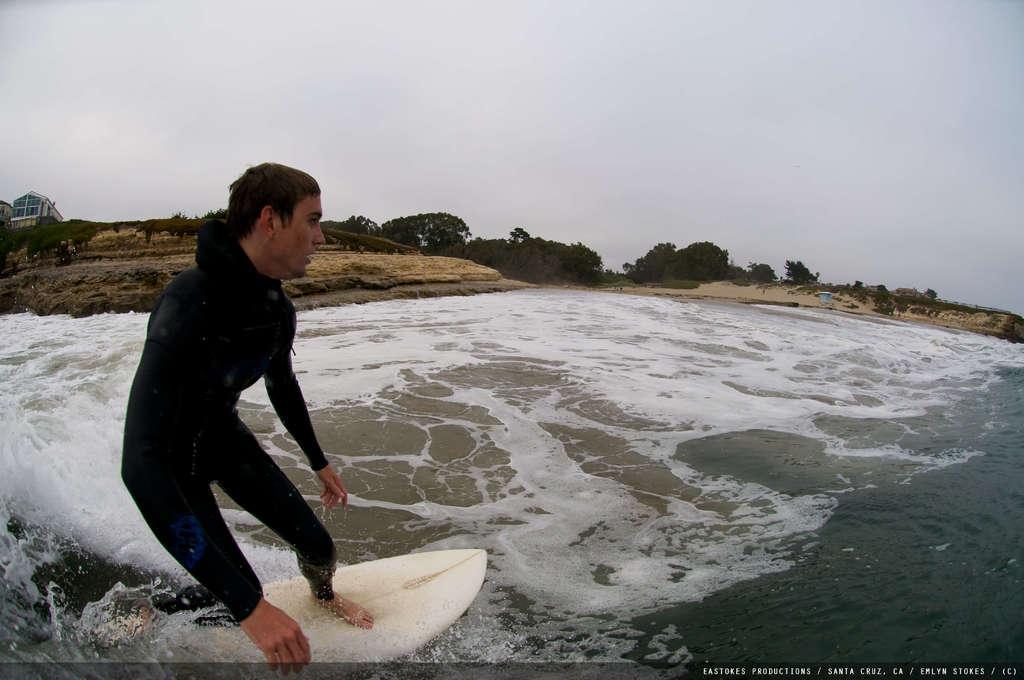Please provide a concise description of this image. In this picture there is a person surfing on the water. On the left side of the image there is a building and at the back there are trees. At the top there is sky. At the bottom there is water. In the bottom right there is a text. 